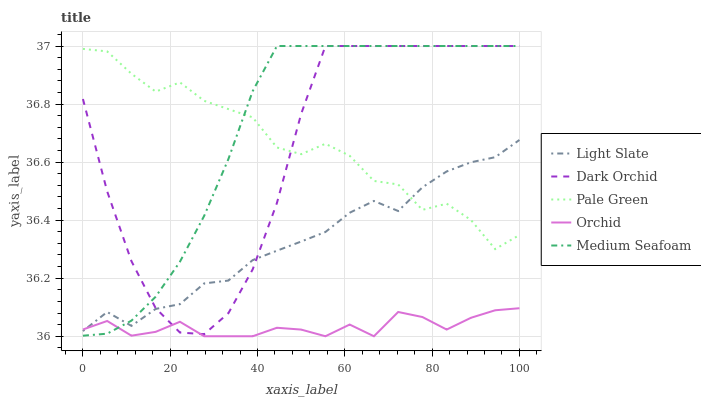Does Orchid have the minimum area under the curve?
Answer yes or no. Yes. Does Medium Seafoam have the maximum area under the curve?
Answer yes or no. Yes. Does Pale Green have the minimum area under the curve?
Answer yes or no. No. Does Pale Green have the maximum area under the curve?
Answer yes or no. No. Is Medium Seafoam the smoothest?
Answer yes or no. Yes. Is Pale Green the roughest?
Answer yes or no. Yes. Is Pale Green the smoothest?
Answer yes or no. No. Is Medium Seafoam the roughest?
Answer yes or no. No. Does Orchid have the lowest value?
Answer yes or no. Yes. Does Medium Seafoam have the lowest value?
Answer yes or no. No. Does Dark Orchid have the highest value?
Answer yes or no. Yes. Does Pale Green have the highest value?
Answer yes or no. No. Is Orchid less than Pale Green?
Answer yes or no. Yes. Is Pale Green greater than Orchid?
Answer yes or no. Yes. Does Light Slate intersect Orchid?
Answer yes or no. Yes. Is Light Slate less than Orchid?
Answer yes or no. No. Is Light Slate greater than Orchid?
Answer yes or no. No. Does Orchid intersect Pale Green?
Answer yes or no. No. 